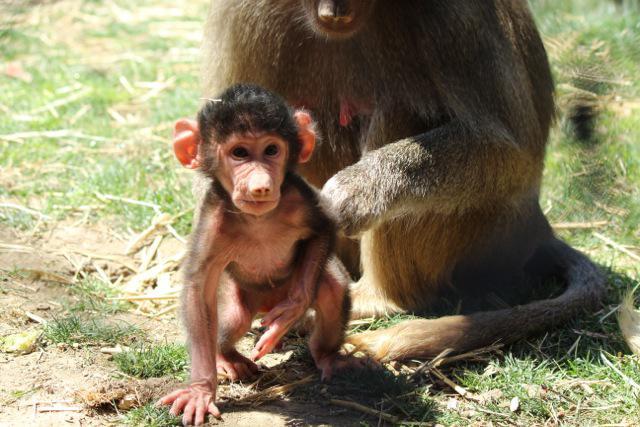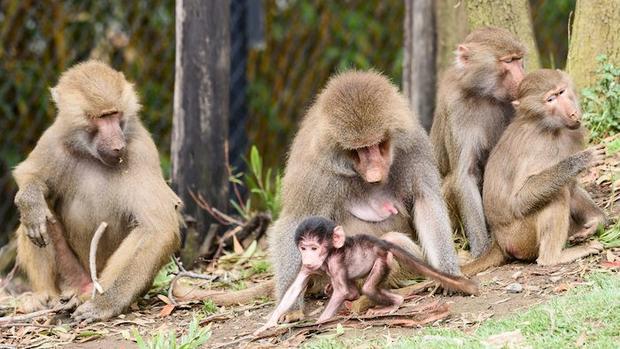The first image is the image on the left, the second image is the image on the right. For the images displayed, is the sentence "One image shows a baby baboon riding on the body of a baboon in profile on all fours." factually correct? Answer yes or no. No. The first image is the image on the left, the second image is the image on the right. Given the left and right images, does the statement "The left image contains no more than two primates." hold true? Answer yes or no. Yes. 